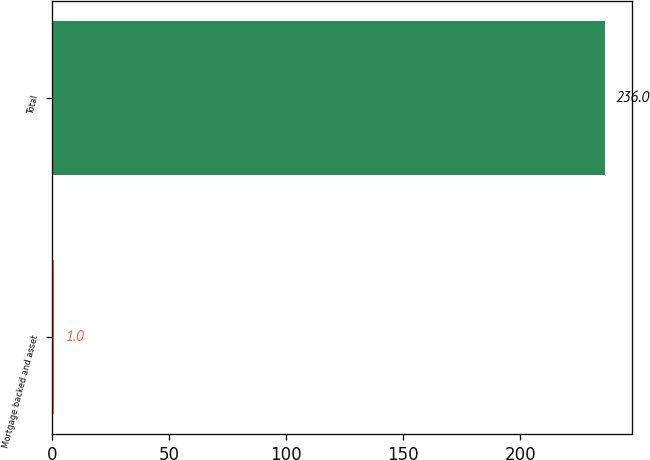Convert chart to OTSL. <chart><loc_0><loc_0><loc_500><loc_500><bar_chart><fcel>Mortgage backed and asset<fcel>Total<nl><fcel>1<fcel>236<nl></chart> 